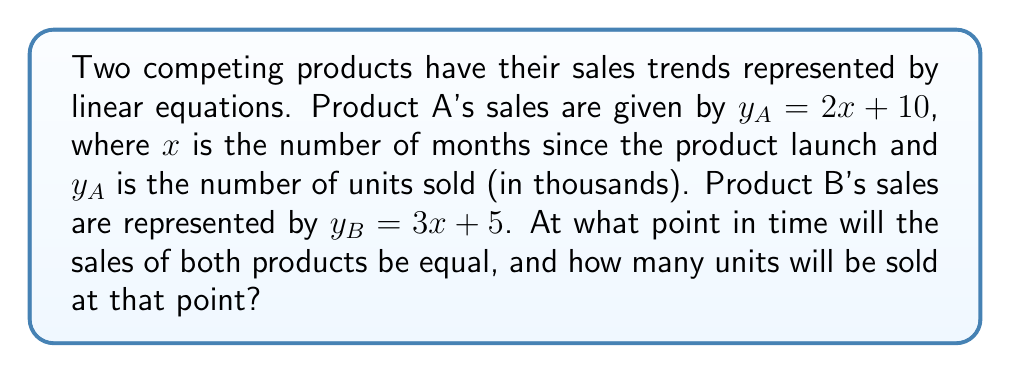What is the answer to this math problem? To find the intersection point of these two lines, we need to solve the system of equations:

$$y_A = 2x + 10$$
$$y_B = 3x + 5$$

At the intersection point, $y_A = y_B$, so we can set the equations equal to each other:

$$2x + 10 = 3x + 5$$

Now, let's solve for $x$:

1) Subtract $2x$ from both sides:
   $$10 = x + 5$$

2) Subtract 5 from both sides:
   $$5 = x$$

So, the intersection occurs when $x = 5$ months.

To find the number of units sold at this point, we can substitute $x = 5$ into either equation. Let's use Product A's equation:

$$y_A = 2(5) + 10 = 20$$

Therefore, the intersection point is $(5, 20)$, meaning after 5 months, both products will have sold 20 thousand units.
Answer: (5, 20) 